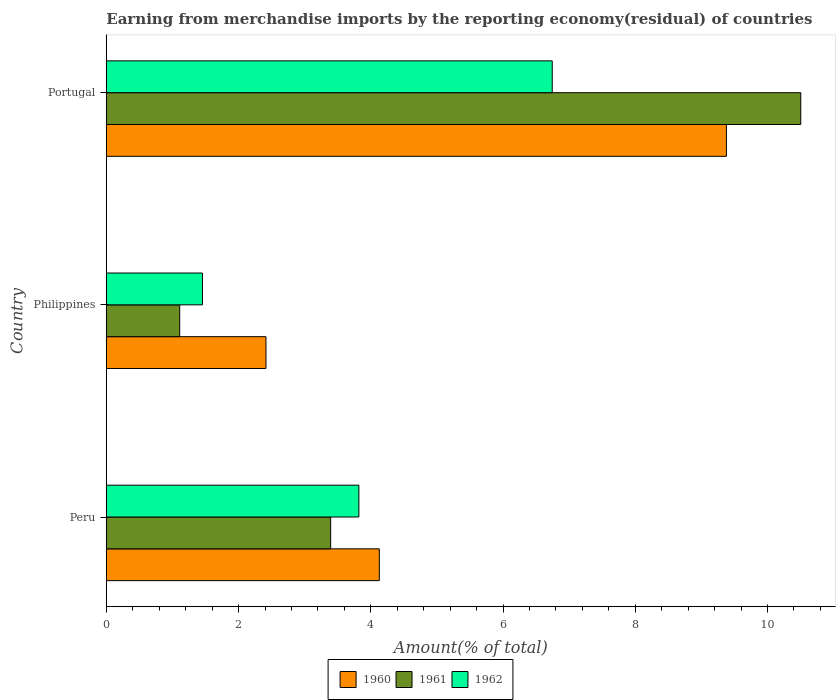How many different coloured bars are there?
Make the answer very short. 3. How many groups of bars are there?
Offer a terse response. 3. Are the number of bars per tick equal to the number of legend labels?
Offer a very short reply. Yes. Are the number of bars on each tick of the Y-axis equal?
Provide a succinct answer. Yes. How many bars are there on the 2nd tick from the top?
Provide a short and direct response. 3. How many bars are there on the 2nd tick from the bottom?
Your answer should be very brief. 3. What is the label of the 1st group of bars from the top?
Your response must be concise. Portugal. What is the percentage of amount earned from merchandise imports in 1962 in Philippines?
Your response must be concise. 1.45. Across all countries, what is the maximum percentage of amount earned from merchandise imports in 1962?
Keep it short and to the point. 6.74. Across all countries, what is the minimum percentage of amount earned from merchandise imports in 1962?
Provide a short and direct response. 1.45. In which country was the percentage of amount earned from merchandise imports in 1962 maximum?
Keep it short and to the point. Portugal. In which country was the percentage of amount earned from merchandise imports in 1962 minimum?
Provide a short and direct response. Philippines. What is the total percentage of amount earned from merchandise imports in 1962 in the graph?
Ensure brevity in your answer.  12.02. What is the difference between the percentage of amount earned from merchandise imports in 1962 in Peru and that in Portugal?
Your response must be concise. -2.92. What is the difference between the percentage of amount earned from merchandise imports in 1961 in Peru and the percentage of amount earned from merchandise imports in 1962 in Portugal?
Give a very brief answer. -3.35. What is the average percentage of amount earned from merchandise imports in 1961 per country?
Your answer should be compact. 5. What is the difference between the percentage of amount earned from merchandise imports in 1961 and percentage of amount earned from merchandise imports in 1962 in Peru?
Your answer should be compact. -0.43. In how many countries, is the percentage of amount earned from merchandise imports in 1961 greater than 0.8 %?
Give a very brief answer. 3. What is the ratio of the percentage of amount earned from merchandise imports in 1962 in Philippines to that in Portugal?
Offer a very short reply. 0.22. Is the difference between the percentage of amount earned from merchandise imports in 1961 in Philippines and Portugal greater than the difference between the percentage of amount earned from merchandise imports in 1962 in Philippines and Portugal?
Your answer should be very brief. No. What is the difference between the highest and the second highest percentage of amount earned from merchandise imports in 1962?
Ensure brevity in your answer.  2.92. What is the difference between the highest and the lowest percentage of amount earned from merchandise imports in 1962?
Give a very brief answer. 5.29. Is the sum of the percentage of amount earned from merchandise imports in 1962 in Peru and Portugal greater than the maximum percentage of amount earned from merchandise imports in 1960 across all countries?
Make the answer very short. Yes. What does the 1st bar from the top in Portugal represents?
Provide a short and direct response. 1962. What does the 2nd bar from the bottom in Philippines represents?
Your response must be concise. 1961. What is the difference between two consecutive major ticks on the X-axis?
Give a very brief answer. 2. How are the legend labels stacked?
Provide a short and direct response. Horizontal. What is the title of the graph?
Ensure brevity in your answer.  Earning from merchandise imports by the reporting economy(residual) of countries. Does "2015" appear as one of the legend labels in the graph?
Your answer should be compact. No. What is the label or title of the X-axis?
Your answer should be very brief. Amount(% of total). What is the Amount(% of total) of 1960 in Peru?
Provide a short and direct response. 4.13. What is the Amount(% of total) of 1961 in Peru?
Provide a short and direct response. 3.39. What is the Amount(% of total) of 1962 in Peru?
Your answer should be very brief. 3.82. What is the Amount(% of total) in 1960 in Philippines?
Your answer should be very brief. 2.41. What is the Amount(% of total) of 1961 in Philippines?
Make the answer very short. 1.11. What is the Amount(% of total) in 1962 in Philippines?
Give a very brief answer. 1.45. What is the Amount(% of total) in 1960 in Portugal?
Your answer should be compact. 9.38. What is the Amount(% of total) in 1961 in Portugal?
Keep it short and to the point. 10.5. What is the Amount(% of total) of 1962 in Portugal?
Give a very brief answer. 6.74. Across all countries, what is the maximum Amount(% of total) in 1960?
Your response must be concise. 9.38. Across all countries, what is the maximum Amount(% of total) in 1961?
Make the answer very short. 10.5. Across all countries, what is the maximum Amount(% of total) in 1962?
Ensure brevity in your answer.  6.74. Across all countries, what is the minimum Amount(% of total) in 1960?
Provide a short and direct response. 2.41. Across all countries, what is the minimum Amount(% of total) in 1961?
Offer a terse response. 1.11. Across all countries, what is the minimum Amount(% of total) of 1962?
Make the answer very short. 1.45. What is the total Amount(% of total) of 1960 in the graph?
Offer a very short reply. 15.92. What is the total Amount(% of total) in 1961 in the graph?
Ensure brevity in your answer.  15.01. What is the total Amount(% of total) in 1962 in the graph?
Provide a succinct answer. 12.02. What is the difference between the Amount(% of total) in 1960 in Peru and that in Philippines?
Provide a succinct answer. 1.71. What is the difference between the Amount(% of total) of 1961 in Peru and that in Philippines?
Provide a short and direct response. 2.28. What is the difference between the Amount(% of total) in 1962 in Peru and that in Philippines?
Provide a short and direct response. 2.37. What is the difference between the Amount(% of total) of 1960 in Peru and that in Portugal?
Offer a terse response. -5.25. What is the difference between the Amount(% of total) in 1961 in Peru and that in Portugal?
Keep it short and to the point. -7.11. What is the difference between the Amount(% of total) of 1962 in Peru and that in Portugal?
Your answer should be very brief. -2.92. What is the difference between the Amount(% of total) in 1960 in Philippines and that in Portugal?
Your response must be concise. -6.96. What is the difference between the Amount(% of total) of 1961 in Philippines and that in Portugal?
Ensure brevity in your answer.  -9.39. What is the difference between the Amount(% of total) in 1962 in Philippines and that in Portugal?
Keep it short and to the point. -5.29. What is the difference between the Amount(% of total) of 1960 in Peru and the Amount(% of total) of 1961 in Philippines?
Provide a succinct answer. 3.02. What is the difference between the Amount(% of total) in 1960 in Peru and the Amount(% of total) in 1962 in Philippines?
Your answer should be very brief. 2.68. What is the difference between the Amount(% of total) in 1961 in Peru and the Amount(% of total) in 1962 in Philippines?
Offer a very short reply. 1.94. What is the difference between the Amount(% of total) of 1960 in Peru and the Amount(% of total) of 1961 in Portugal?
Keep it short and to the point. -6.37. What is the difference between the Amount(% of total) of 1960 in Peru and the Amount(% of total) of 1962 in Portugal?
Your answer should be very brief. -2.62. What is the difference between the Amount(% of total) in 1961 in Peru and the Amount(% of total) in 1962 in Portugal?
Offer a very short reply. -3.35. What is the difference between the Amount(% of total) of 1960 in Philippines and the Amount(% of total) of 1961 in Portugal?
Offer a very short reply. -8.09. What is the difference between the Amount(% of total) of 1960 in Philippines and the Amount(% of total) of 1962 in Portugal?
Offer a terse response. -4.33. What is the difference between the Amount(% of total) in 1961 in Philippines and the Amount(% of total) in 1962 in Portugal?
Your response must be concise. -5.63. What is the average Amount(% of total) in 1960 per country?
Your answer should be very brief. 5.31. What is the average Amount(% of total) of 1961 per country?
Provide a short and direct response. 5. What is the average Amount(% of total) in 1962 per country?
Your answer should be compact. 4.01. What is the difference between the Amount(% of total) of 1960 and Amount(% of total) of 1961 in Peru?
Make the answer very short. 0.74. What is the difference between the Amount(% of total) of 1960 and Amount(% of total) of 1962 in Peru?
Your response must be concise. 0.31. What is the difference between the Amount(% of total) of 1961 and Amount(% of total) of 1962 in Peru?
Your answer should be very brief. -0.43. What is the difference between the Amount(% of total) of 1960 and Amount(% of total) of 1961 in Philippines?
Ensure brevity in your answer.  1.3. What is the difference between the Amount(% of total) in 1960 and Amount(% of total) in 1962 in Philippines?
Make the answer very short. 0.96. What is the difference between the Amount(% of total) in 1961 and Amount(% of total) in 1962 in Philippines?
Offer a very short reply. -0.34. What is the difference between the Amount(% of total) in 1960 and Amount(% of total) in 1961 in Portugal?
Your answer should be compact. -1.12. What is the difference between the Amount(% of total) of 1960 and Amount(% of total) of 1962 in Portugal?
Make the answer very short. 2.63. What is the difference between the Amount(% of total) in 1961 and Amount(% of total) in 1962 in Portugal?
Make the answer very short. 3.76. What is the ratio of the Amount(% of total) of 1960 in Peru to that in Philippines?
Provide a short and direct response. 1.71. What is the ratio of the Amount(% of total) in 1961 in Peru to that in Philippines?
Your answer should be very brief. 3.06. What is the ratio of the Amount(% of total) of 1962 in Peru to that in Philippines?
Keep it short and to the point. 2.63. What is the ratio of the Amount(% of total) in 1960 in Peru to that in Portugal?
Keep it short and to the point. 0.44. What is the ratio of the Amount(% of total) of 1961 in Peru to that in Portugal?
Ensure brevity in your answer.  0.32. What is the ratio of the Amount(% of total) in 1962 in Peru to that in Portugal?
Ensure brevity in your answer.  0.57. What is the ratio of the Amount(% of total) in 1960 in Philippines to that in Portugal?
Your response must be concise. 0.26. What is the ratio of the Amount(% of total) of 1961 in Philippines to that in Portugal?
Offer a very short reply. 0.11. What is the ratio of the Amount(% of total) in 1962 in Philippines to that in Portugal?
Ensure brevity in your answer.  0.22. What is the difference between the highest and the second highest Amount(% of total) in 1960?
Ensure brevity in your answer.  5.25. What is the difference between the highest and the second highest Amount(% of total) of 1961?
Ensure brevity in your answer.  7.11. What is the difference between the highest and the second highest Amount(% of total) in 1962?
Offer a very short reply. 2.92. What is the difference between the highest and the lowest Amount(% of total) in 1960?
Make the answer very short. 6.96. What is the difference between the highest and the lowest Amount(% of total) in 1961?
Your answer should be very brief. 9.39. What is the difference between the highest and the lowest Amount(% of total) in 1962?
Provide a short and direct response. 5.29. 